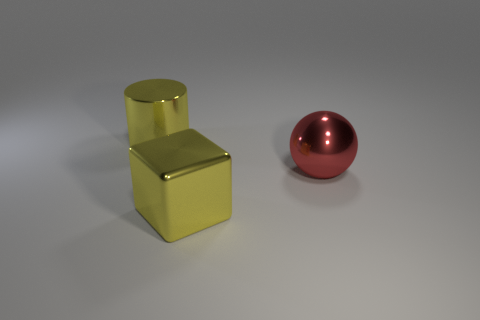Add 3 shiny cubes. How many objects exist? 6 Subtract all cylinders. How many objects are left? 2 Add 3 shiny objects. How many shiny objects are left? 6 Add 2 tiny matte balls. How many tiny matte balls exist? 2 Subtract 0 blue balls. How many objects are left? 3 Subtract all green balls. Subtract all big yellow shiny blocks. How many objects are left? 2 